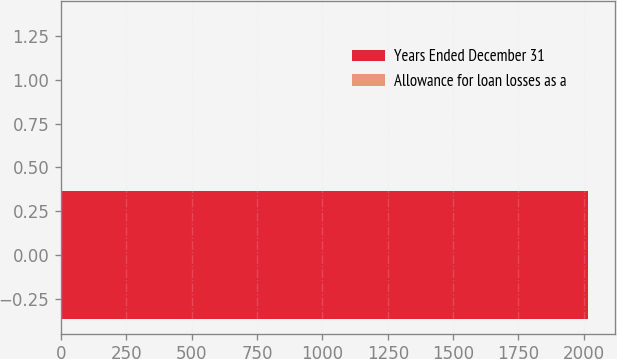Convert chart to OTSL. <chart><loc_0><loc_0><loc_500><loc_500><bar_chart><fcel>Years Ended December 31<fcel>Allowance for loan losses as a<nl><fcel>2017<fcel>1.45<nl></chart> 